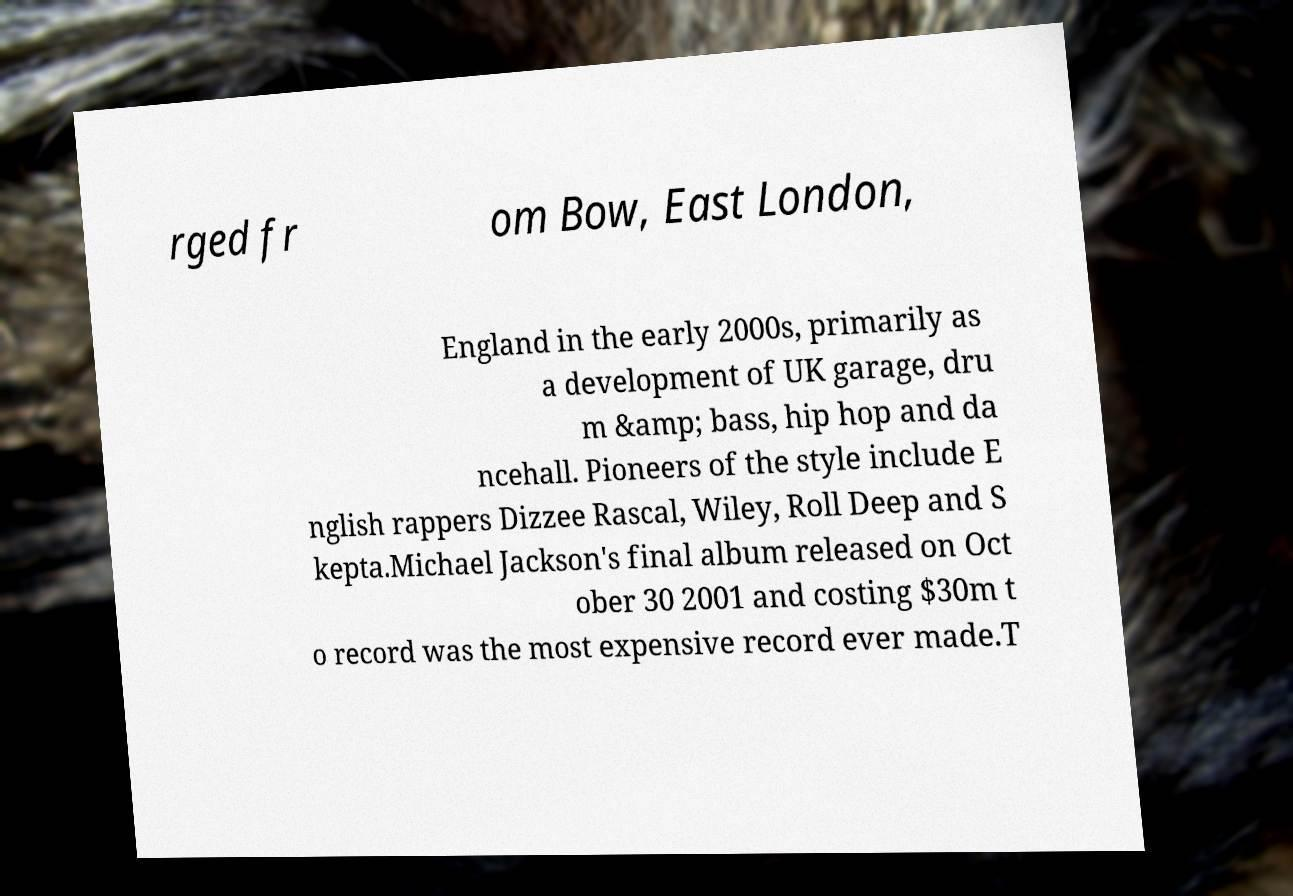There's text embedded in this image that I need extracted. Can you transcribe it verbatim? rged fr om Bow, East London, England in the early 2000s, primarily as a development of UK garage, dru m &amp; bass, hip hop and da ncehall. Pioneers of the style include E nglish rappers Dizzee Rascal, Wiley, Roll Deep and S kepta.Michael Jackson's final album released on Oct ober 30 2001 and costing $30m t o record was the most expensive record ever made.T 